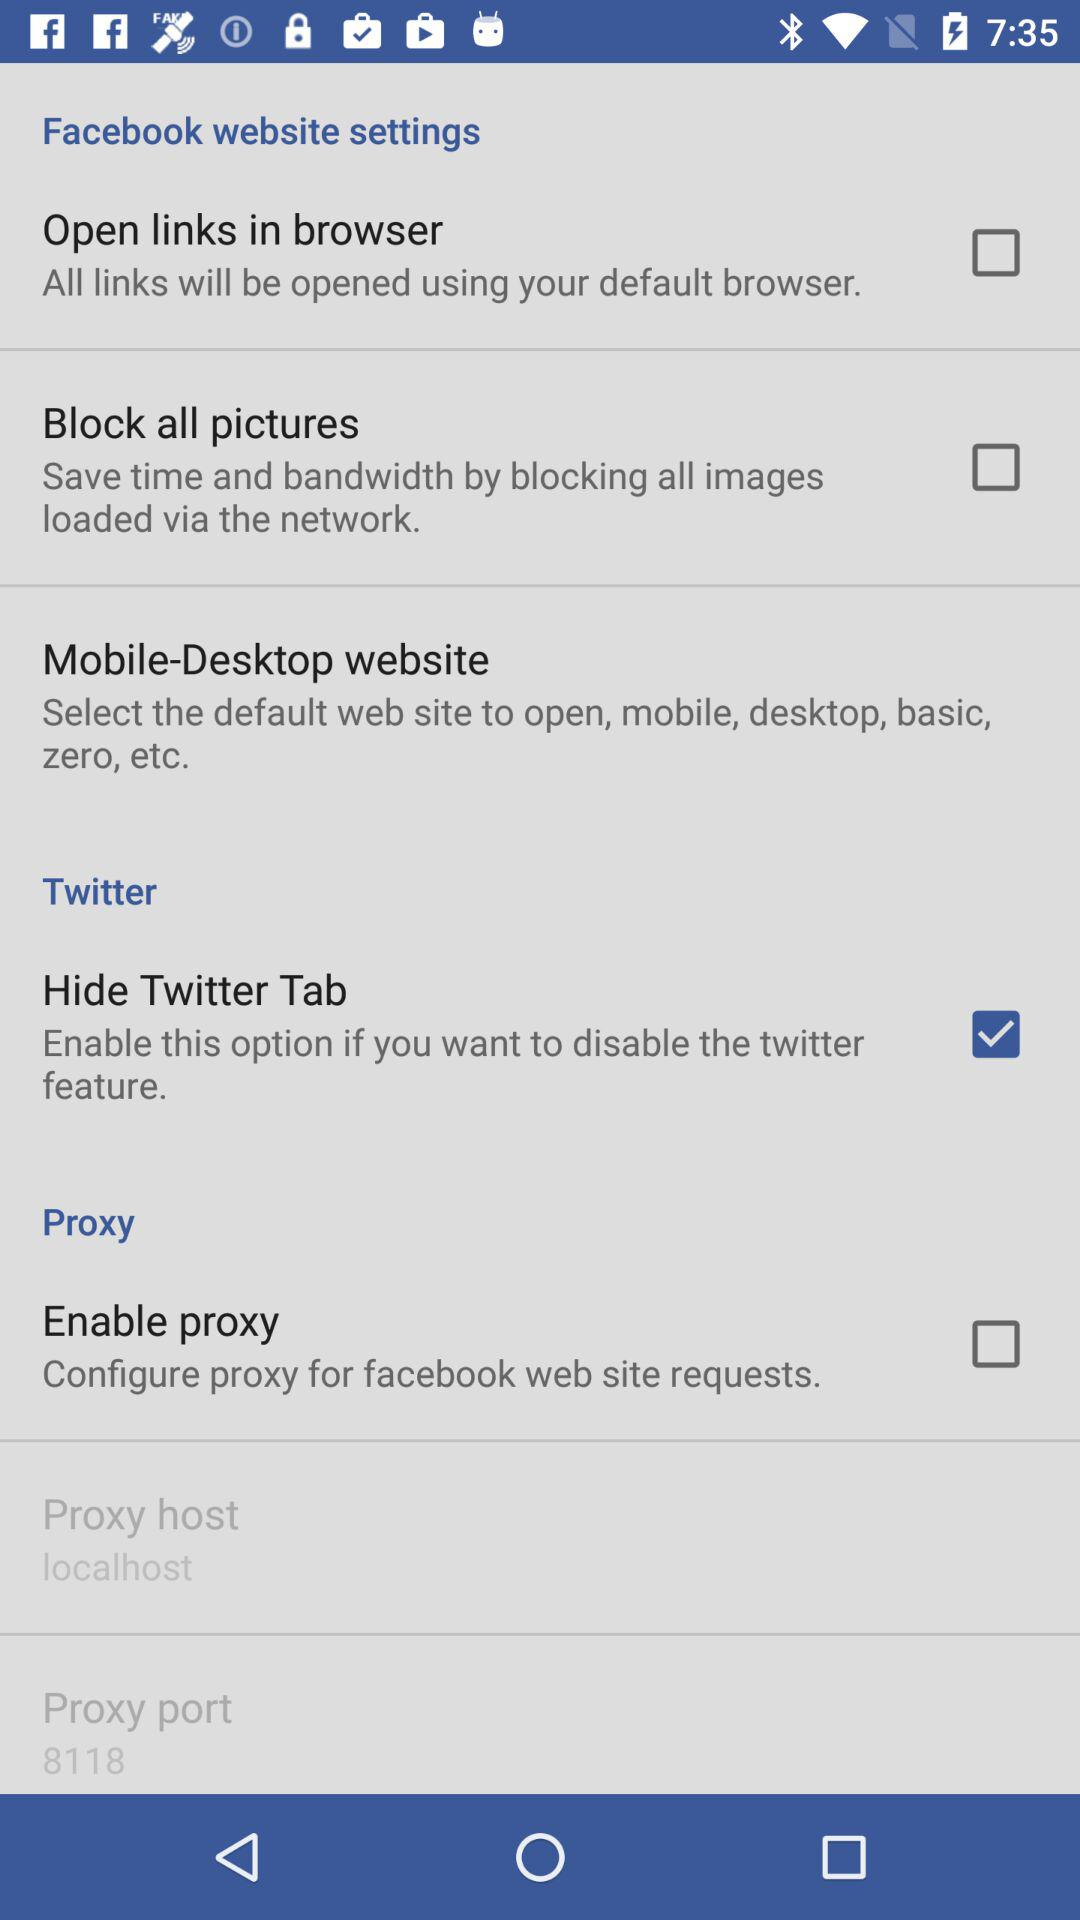What is the selected proxy host? The selected proxy host is "localhost". 